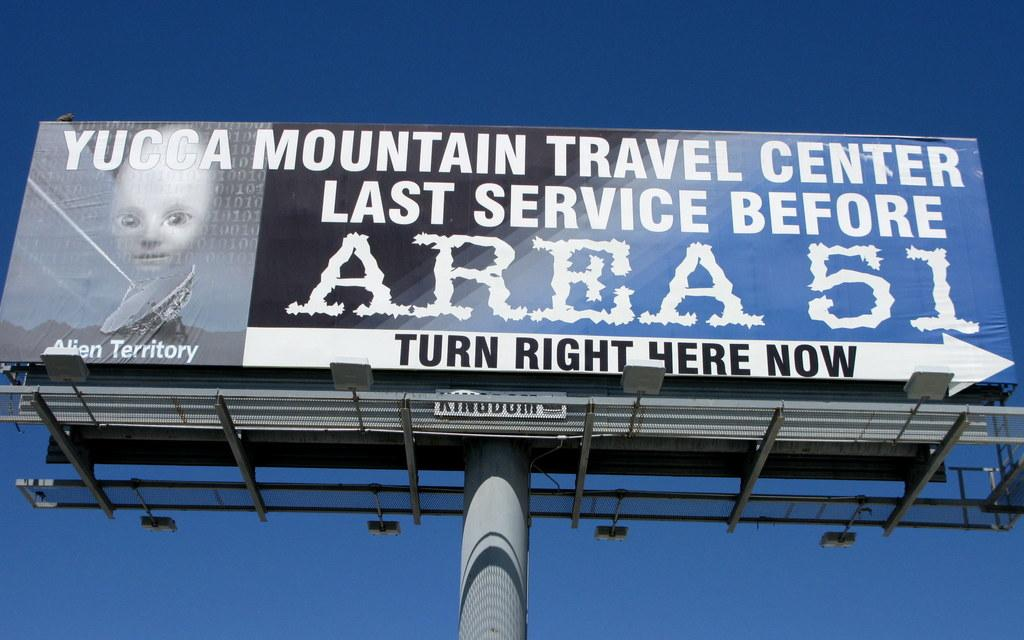<image>
Summarize the visual content of the image. A billboard for Mountain Travel Center stands high in the sky. 